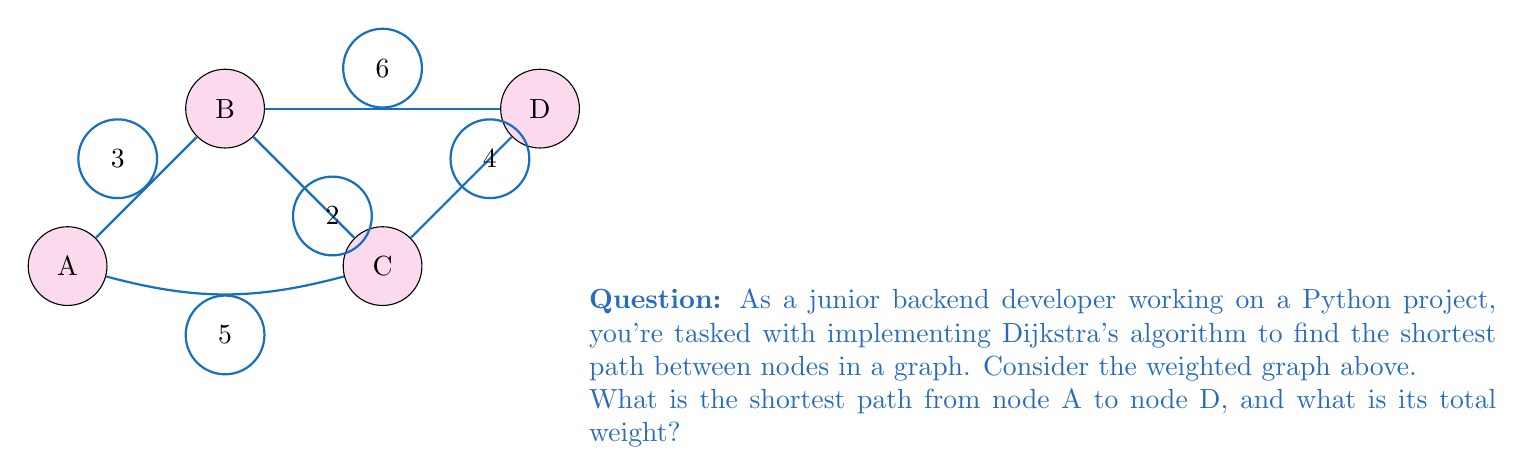Can you answer this question? To solve this problem using Dijkstra's algorithm, we'll follow these steps:

1) Initialize distances:
   A: 0 (starting node)
   B: $\infty$
   C: $\infty$
   D: $\infty$

2) Set A as the current node and update its neighbors:
   B: min($\infty$, 0 + 3) = 3
   C: min($\infty$, 0 + 5) = 5

3) Mark A as visited, choose the node with the smallest distance (B), and update its neighbors:
   C: min(5, 3 + 2) = 5
   D: min($\infty$, 3 + 6) = 9

4) Mark B as visited, choose the node with the smallest distance (C), and update its neighbors:
   D: min(9, 5 + 4) = 9

5) Mark C as visited, and update D (the only unvisited node):
   D: min(9, 5 + 4) = 9

6) Mark D as visited. All nodes are now visited, so the algorithm terminates.

The shortest path from A to D is A → C → D, with a total weight of 5 + 4 = 9.
Answer: Path: A → C → D, Weight: 9 